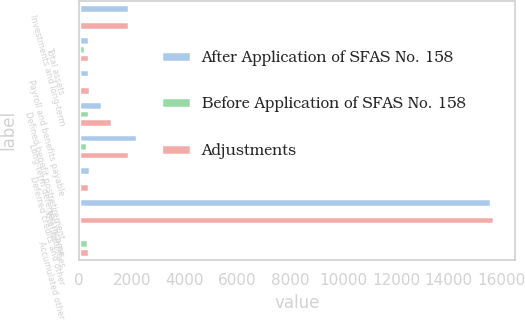Convert chart to OTSL. <chart><loc_0><loc_0><loc_500><loc_500><stacked_bar_chart><ecel><fcel>Investments and long-term<fcel>Total assets<fcel>Payroll and benefits payable<fcel>Defined benefit postretirement<fcel>Long-term deferred income<fcel>Deferred credits and other<fcel>Total liabilities<fcel>Accumulated other<nl><fcel>After Application of SFAS No. 158<fcel>1893<fcel>387.5<fcel>384<fcel>870<fcel>2183<fcel>397<fcel>15598<fcel>25<nl><fcel>Before Application of SFAS No. 158<fcel>6<fcel>235<fcel>25<fcel>375<fcel>286<fcel>6<fcel>108<fcel>343<nl><fcel>Adjustments<fcel>1887<fcel>387.5<fcel>409<fcel>1245<fcel>1897<fcel>391<fcel>15706<fcel>368<nl></chart> 